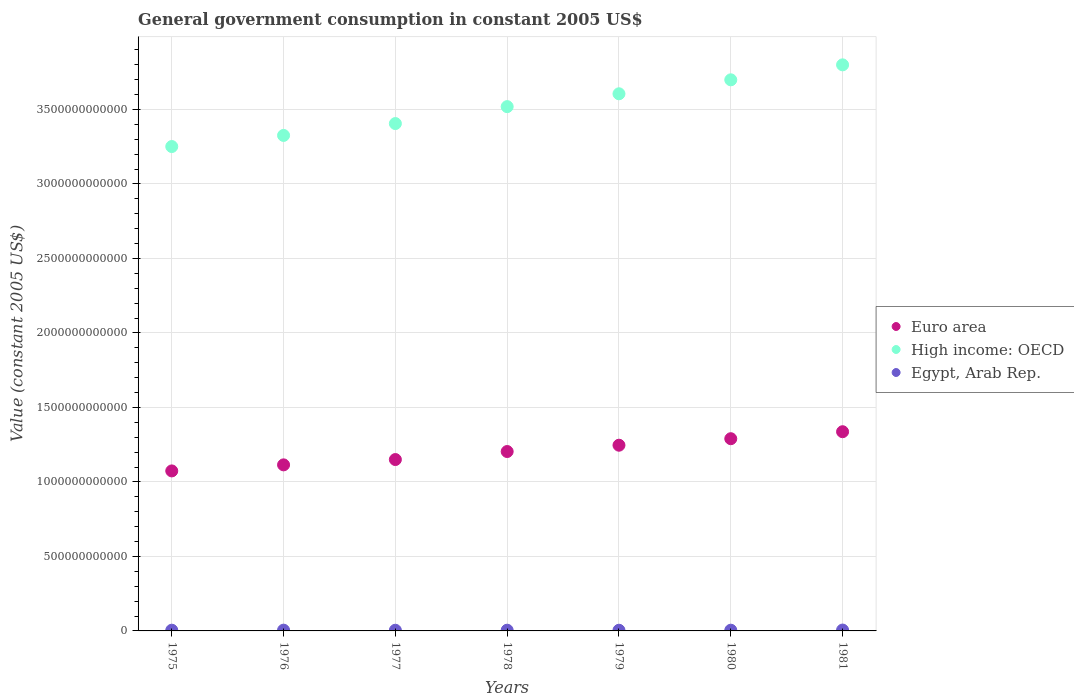How many different coloured dotlines are there?
Offer a very short reply. 3. Is the number of dotlines equal to the number of legend labels?
Provide a short and direct response. Yes. What is the government conusmption in Egypt, Arab Rep. in 1975?
Provide a short and direct response. 4.83e+09. Across all years, what is the maximum government conusmption in Egypt, Arab Rep.?
Give a very brief answer. 5.85e+09. Across all years, what is the minimum government conusmption in High income: OECD?
Offer a terse response. 3.25e+12. In which year was the government conusmption in Euro area maximum?
Offer a terse response. 1981. In which year was the government conusmption in Egypt, Arab Rep. minimum?
Your answer should be very brief. 1979. What is the total government conusmption in Euro area in the graph?
Offer a terse response. 8.42e+12. What is the difference between the government conusmption in Euro area in 1976 and that in 1979?
Make the answer very short. -1.32e+11. What is the difference between the government conusmption in Egypt, Arab Rep. in 1978 and the government conusmption in Euro area in 1977?
Give a very brief answer. -1.15e+12. What is the average government conusmption in Egypt, Arab Rep. per year?
Offer a terse response. 4.94e+09. In the year 1977, what is the difference between the government conusmption in Euro area and government conusmption in Egypt, Arab Rep.?
Offer a very short reply. 1.15e+12. In how many years, is the government conusmption in Euro area greater than 1100000000000 US$?
Provide a short and direct response. 6. What is the ratio of the government conusmption in High income: OECD in 1979 to that in 1980?
Offer a very short reply. 0.97. Is the government conusmption in Euro area in 1977 less than that in 1978?
Keep it short and to the point. Yes. What is the difference between the highest and the second highest government conusmption in High income: OECD?
Your answer should be very brief. 1.01e+11. What is the difference between the highest and the lowest government conusmption in High income: OECD?
Keep it short and to the point. 5.48e+11. Is the sum of the government conusmption in Euro area in 1978 and 1981 greater than the maximum government conusmption in Egypt, Arab Rep. across all years?
Your response must be concise. Yes. Is it the case that in every year, the sum of the government conusmption in Euro area and government conusmption in Egypt, Arab Rep.  is greater than the government conusmption in High income: OECD?
Keep it short and to the point. No. Does the government conusmption in Egypt, Arab Rep. monotonically increase over the years?
Make the answer very short. No. Is the government conusmption in Euro area strictly greater than the government conusmption in Egypt, Arab Rep. over the years?
Give a very brief answer. Yes. Is the government conusmption in Euro area strictly less than the government conusmption in High income: OECD over the years?
Provide a succinct answer. Yes. How many dotlines are there?
Offer a very short reply. 3. How many years are there in the graph?
Provide a short and direct response. 7. What is the difference between two consecutive major ticks on the Y-axis?
Provide a short and direct response. 5.00e+11. Are the values on the major ticks of Y-axis written in scientific E-notation?
Offer a very short reply. No. Does the graph contain any zero values?
Offer a terse response. No. Does the graph contain grids?
Ensure brevity in your answer.  Yes. Where does the legend appear in the graph?
Offer a very short reply. Center right. How many legend labels are there?
Offer a terse response. 3. How are the legend labels stacked?
Your response must be concise. Vertical. What is the title of the graph?
Your response must be concise. General government consumption in constant 2005 US$. What is the label or title of the Y-axis?
Provide a succinct answer. Value (constant 2005 US$). What is the Value (constant 2005 US$) of Euro area in 1975?
Your response must be concise. 1.07e+12. What is the Value (constant 2005 US$) in High income: OECD in 1975?
Your answer should be compact. 3.25e+12. What is the Value (constant 2005 US$) of Egypt, Arab Rep. in 1975?
Give a very brief answer. 4.83e+09. What is the Value (constant 2005 US$) in Euro area in 1976?
Provide a succinct answer. 1.11e+12. What is the Value (constant 2005 US$) of High income: OECD in 1976?
Keep it short and to the point. 3.33e+12. What is the Value (constant 2005 US$) in Egypt, Arab Rep. in 1976?
Your answer should be compact. 5.14e+09. What is the Value (constant 2005 US$) in Euro area in 1977?
Give a very brief answer. 1.15e+12. What is the Value (constant 2005 US$) in High income: OECD in 1977?
Give a very brief answer. 3.41e+12. What is the Value (constant 2005 US$) of Egypt, Arab Rep. in 1977?
Ensure brevity in your answer.  4.53e+09. What is the Value (constant 2005 US$) of Euro area in 1978?
Provide a short and direct response. 1.20e+12. What is the Value (constant 2005 US$) in High income: OECD in 1978?
Your answer should be compact. 3.52e+12. What is the Value (constant 2005 US$) in Egypt, Arab Rep. in 1978?
Offer a very short reply. 4.90e+09. What is the Value (constant 2005 US$) of Euro area in 1979?
Your answer should be compact. 1.25e+12. What is the Value (constant 2005 US$) of High income: OECD in 1979?
Provide a short and direct response. 3.61e+12. What is the Value (constant 2005 US$) of Egypt, Arab Rep. in 1979?
Give a very brief answer. 4.53e+09. What is the Value (constant 2005 US$) in Euro area in 1980?
Offer a terse response. 1.29e+12. What is the Value (constant 2005 US$) in High income: OECD in 1980?
Your answer should be compact. 3.70e+12. What is the Value (constant 2005 US$) in Egypt, Arab Rep. in 1980?
Your answer should be very brief. 4.83e+09. What is the Value (constant 2005 US$) in Euro area in 1981?
Offer a terse response. 1.34e+12. What is the Value (constant 2005 US$) in High income: OECD in 1981?
Provide a succinct answer. 3.80e+12. What is the Value (constant 2005 US$) of Egypt, Arab Rep. in 1981?
Provide a short and direct response. 5.85e+09. Across all years, what is the maximum Value (constant 2005 US$) of Euro area?
Provide a short and direct response. 1.34e+12. Across all years, what is the maximum Value (constant 2005 US$) in High income: OECD?
Offer a very short reply. 3.80e+12. Across all years, what is the maximum Value (constant 2005 US$) of Egypt, Arab Rep.?
Your answer should be very brief. 5.85e+09. Across all years, what is the minimum Value (constant 2005 US$) of Euro area?
Your response must be concise. 1.07e+12. Across all years, what is the minimum Value (constant 2005 US$) of High income: OECD?
Keep it short and to the point. 3.25e+12. Across all years, what is the minimum Value (constant 2005 US$) of Egypt, Arab Rep.?
Give a very brief answer. 4.53e+09. What is the total Value (constant 2005 US$) in Euro area in the graph?
Provide a short and direct response. 8.42e+12. What is the total Value (constant 2005 US$) in High income: OECD in the graph?
Keep it short and to the point. 2.46e+13. What is the total Value (constant 2005 US$) in Egypt, Arab Rep. in the graph?
Offer a terse response. 3.46e+1. What is the difference between the Value (constant 2005 US$) of Euro area in 1975 and that in 1976?
Offer a terse response. -4.07e+1. What is the difference between the Value (constant 2005 US$) in High income: OECD in 1975 and that in 1976?
Keep it short and to the point. -7.46e+1. What is the difference between the Value (constant 2005 US$) of Egypt, Arab Rep. in 1975 and that in 1976?
Ensure brevity in your answer.  -3.16e+08. What is the difference between the Value (constant 2005 US$) in Euro area in 1975 and that in 1977?
Ensure brevity in your answer.  -7.63e+1. What is the difference between the Value (constant 2005 US$) in High income: OECD in 1975 and that in 1977?
Give a very brief answer. -1.54e+11. What is the difference between the Value (constant 2005 US$) of Egypt, Arab Rep. in 1975 and that in 1977?
Provide a succinct answer. 2.92e+08. What is the difference between the Value (constant 2005 US$) in Euro area in 1975 and that in 1978?
Your response must be concise. -1.30e+11. What is the difference between the Value (constant 2005 US$) in High income: OECD in 1975 and that in 1978?
Keep it short and to the point. -2.68e+11. What is the difference between the Value (constant 2005 US$) in Egypt, Arab Rep. in 1975 and that in 1978?
Provide a succinct answer. -7.05e+07. What is the difference between the Value (constant 2005 US$) in Euro area in 1975 and that in 1979?
Keep it short and to the point. -1.73e+11. What is the difference between the Value (constant 2005 US$) in High income: OECD in 1975 and that in 1979?
Your response must be concise. -3.54e+11. What is the difference between the Value (constant 2005 US$) in Egypt, Arab Rep. in 1975 and that in 1979?
Your answer should be compact. 2.98e+08. What is the difference between the Value (constant 2005 US$) of Euro area in 1975 and that in 1980?
Provide a succinct answer. -2.16e+11. What is the difference between the Value (constant 2005 US$) in High income: OECD in 1975 and that in 1980?
Give a very brief answer. -4.48e+11. What is the difference between the Value (constant 2005 US$) of Egypt, Arab Rep. in 1975 and that in 1980?
Offer a terse response. -2.20e+06. What is the difference between the Value (constant 2005 US$) of Euro area in 1975 and that in 1981?
Provide a succinct answer. -2.63e+11. What is the difference between the Value (constant 2005 US$) in High income: OECD in 1975 and that in 1981?
Offer a very short reply. -5.48e+11. What is the difference between the Value (constant 2005 US$) of Egypt, Arab Rep. in 1975 and that in 1981?
Provide a succinct answer. -1.02e+09. What is the difference between the Value (constant 2005 US$) of Euro area in 1976 and that in 1977?
Provide a succinct answer. -3.57e+1. What is the difference between the Value (constant 2005 US$) of High income: OECD in 1976 and that in 1977?
Your answer should be very brief. -7.96e+1. What is the difference between the Value (constant 2005 US$) of Egypt, Arab Rep. in 1976 and that in 1977?
Provide a short and direct response. 6.08e+08. What is the difference between the Value (constant 2005 US$) in Euro area in 1976 and that in 1978?
Keep it short and to the point. -8.95e+1. What is the difference between the Value (constant 2005 US$) in High income: OECD in 1976 and that in 1978?
Ensure brevity in your answer.  -1.93e+11. What is the difference between the Value (constant 2005 US$) in Egypt, Arab Rep. in 1976 and that in 1978?
Your response must be concise. 2.46e+08. What is the difference between the Value (constant 2005 US$) in Euro area in 1976 and that in 1979?
Keep it short and to the point. -1.32e+11. What is the difference between the Value (constant 2005 US$) of High income: OECD in 1976 and that in 1979?
Give a very brief answer. -2.79e+11. What is the difference between the Value (constant 2005 US$) of Egypt, Arab Rep. in 1976 and that in 1979?
Make the answer very short. 6.15e+08. What is the difference between the Value (constant 2005 US$) in Euro area in 1976 and that in 1980?
Make the answer very short. -1.76e+11. What is the difference between the Value (constant 2005 US$) in High income: OECD in 1976 and that in 1980?
Ensure brevity in your answer.  -3.73e+11. What is the difference between the Value (constant 2005 US$) of Egypt, Arab Rep. in 1976 and that in 1980?
Your response must be concise. 3.14e+08. What is the difference between the Value (constant 2005 US$) of Euro area in 1976 and that in 1981?
Give a very brief answer. -2.22e+11. What is the difference between the Value (constant 2005 US$) of High income: OECD in 1976 and that in 1981?
Your answer should be compact. -4.74e+11. What is the difference between the Value (constant 2005 US$) in Egypt, Arab Rep. in 1976 and that in 1981?
Your response must be concise. -7.06e+08. What is the difference between the Value (constant 2005 US$) of Euro area in 1977 and that in 1978?
Keep it short and to the point. -5.39e+1. What is the difference between the Value (constant 2005 US$) in High income: OECD in 1977 and that in 1978?
Provide a short and direct response. -1.14e+11. What is the difference between the Value (constant 2005 US$) of Egypt, Arab Rep. in 1977 and that in 1978?
Your answer should be very brief. -3.62e+08. What is the difference between the Value (constant 2005 US$) of Euro area in 1977 and that in 1979?
Provide a short and direct response. -9.62e+1. What is the difference between the Value (constant 2005 US$) of High income: OECD in 1977 and that in 1979?
Your answer should be compact. -2.00e+11. What is the difference between the Value (constant 2005 US$) in Egypt, Arab Rep. in 1977 and that in 1979?
Your answer should be compact. 6.61e+06. What is the difference between the Value (constant 2005 US$) in Euro area in 1977 and that in 1980?
Keep it short and to the point. -1.40e+11. What is the difference between the Value (constant 2005 US$) of High income: OECD in 1977 and that in 1980?
Make the answer very short. -2.94e+11. What is the difference between the Value (constant 2005 US$) of Egypt, Arab Rep. in 1977 and that in 1980?
Your answer should be compact. -2.94e+08. What is the difference between the Value (constant 2005 US$) in Euro area in 1977 and that in 1981?
Your answer should be compact. -1.87e+11. What is the difference between the Value (constant 2005 US$) in High income: OECD in 1977 and that in 1981?
Offer a terse response. -3.94e+11. What is the difference between the Value (constant 2005 US$) of Egypt, Arab Rep. in 1977 and that in 1981?
Your response must be concise. -1.31e+09. What is the difference between the Value (constant 2005 US$) in Euro area in 1978 and that in 1979?
Give a very brief answer. -4.24e+1. What is the difference between the Value (constant 2005 US$) of High income: OECD in 1978 and that in 1979?
Offer a terse response. -8.62e+1. What is the difference between the Value (constant 2005 US$) of Egypt, Arab Rep. in 1978 and that in 1979?
Offer a very short reply. 3.69e+08. What is the difference between the Value (constant 2005 US$) in Euro area in 1978 and that in 1980?
Provide a short and direct response. -8.60e+1. What is the difference between the Value (constant 2005 US$) in High income: OECD in 1978 and that in 1980?
Make the answer very short. -1.80e+11. What is the difference between the Value (constant 2005 US$) in Egypt, Arab Rep. in 1978 and that in 1980?
Your response must be concise. 6.83e+07. What is the difference between the Value (constant 2005 US$) in Euro area in 1978 and that in 1981?
Offer a very short reply. -1.33e+11. What is the difference between the Value (constant 2005 US$) in High income: OECD in 1978 and that in 1981?
Provide a short and direct response. -2.80e+11. What is the difference between the Value (constant 2005 US$) in Egypt, Arab Rep. in 1978 and that in 1981?
Your answer should be compact. -9.52e+08. What is the difference between the Value (constant 2005 US$) of Euro area in 1979 and that in 1980?
Make the answer very short. -4.37e+1. What is the difference between the Value (constant 2005 US$) in High income: OECD in 1979 and that in 1980?
Keep it short and to the point. -9.37e+1. What is the difference between the Value (constant 2005 US$) in Egypt, Arab Rep. in 1979 and that in 1980?
Your answer should be compact. -3.01e+08. What is the difference between the Value (constant 2005 US$) in Euro area in 1979 and that in 1981?
Your answer should be very brief. -9.06e+1. What is the difference between the Value (constant 2005 US$) of High income: OECD in 1979 and that in 1981?
Your response must be concise. -1.94e+11. What is the difference between the Value (constant 2005 US$) in Egypt, Arab Rep. in 1979 and that in 1981?
Ensure brevity in your answer.  -1.32e+09. What is the difference between the Value (constant 2005 US$) in Euro area in 1980 and that in 1981?
Keep it short and to the point. -4.69e+1. What is the difference between the Value (constant 2005 US$) of High income: OECD in 1980 and that in 1981?
Give a very brief answer. -1.01e+11. What is the difference between the Value (constant 2005 US$) in Egypt, Arab Rep. in 1980 and that in 1981?
Offer a very short reply. -1.02e+09. What is the difference between the Value (constant 2005 US$) in Euro area in 1975 and the Value (constant 2005 US$) in High income: OECD in 1976?
Your answer should be compact. -2.25e+12. What is the difference between the Value (constant 2005 US$) of Euro area in 1975 and the Value (constant 2005 US$) of Egypt, Arab Rep. in 1976?
Provide a short and direct response. 1.07e+12. What is the difference between the Value (constant 2005 US$) in High income: OECD in 1975 and the Value (constant 2005 US$) in Egypt, Arab Rep. in 1976?
Your answer should be compact. 3.25e+12. What is the difference between the Value (constant 2005 US$) of Euro area in 1975 and the Value (constant 2005 US$) of High income: OECD in 1977?
Your response must be concise. -2.33e+12. What is the difference between the Value (constant 2005 US$) of Euro area in 1975 and the Value (constant 2005 US$) of Egypt, Arab Rep. in 1977?
Your answer should be very brief. 1.07e+12. What is the difference between the Value (constant 2005 US$) in High income: OECD in 1975 and the Value (constant 2005 US$) in Egypt, Arab Rep. in 1977?
Ensure brevity in your answer.  3.25e+12. What is the difference between the Value (constant 2005 US$) in Euro area in 1975 and the Value (constant 2005 US$) in High income: OECD in 1978?
Provide a short and direct response. -2.44e+12. What is the difference between the Value (constant 2005 US$) in Euro area in 1975 and the Value (constant 2005 US$) in Egypt, Arab Rep. in 1978?
Keep it short and to the point. 1.07e+12. What is the difference between the Value (constant 2005 US$) of High income: OECD in 1975 and the Value (constant 2005 US$) of Egypt, Arab Rep. in 1978?
Give a very brief answer. 3.25e+12. What is the difference between the Value (constant 2005 US$) in Euro area in 1975 and the Value (constant 2005 US$) in High income: OECD in 1979?
Offer a very short reply. -2.53e+12. What is the difference between the Value (constant 2005 US$) of Euro area in 1975 and the Value (constant 2005 US$) of Egypt, Arab Rep. in 1979?
Keep it short and to the point. 1.07e+12. What is the difference between the Value (constant 2005 US$) of High income: OECD in 1975 and the Value (constant 2005 US$) of Egypt, Arab Rep. in 1979?
Offer a very short reply. 3.25e+12. What is the difference between the Value (constant 2005 US$) in Euro area in 1975 and the Value (constant 2005 US$) in High income: OECD in 1980?
Make the answer very short. -2.62e+12. What is the difference between the Value (constant 2005 US$) of Euro area in 1975 and the Value (constant 2005 US$) of Egypt, Arab Rep. in 1980?
Ensure brevity in your answer.  1.07e+12. What is the difference between the Value (constant 2005 US$) in High income: OECD in 1975 and the Value (constant 2005 US$) in Egypt, Arab Rep. in 1980?
Give a very brief answer. 3.25e+12. What is the difference between the Value (constant 2005 US$) in Euro area in 1975 and the Value (constant 2005 US$) in High income: OECD in 1981?
Offer a very short reply. -2.73e+12. What is the difference between the Value (constant 2005 US$) in Euro area in 1975 and the Value (constant 2005 US$) in Egypt, Arab Rep. in 1981?
Your answer should be compact. 1.07e+12. What is the difference between the Value (constant 2005 US$) in High income: OECD in 1975 and the Value (constant 2005 US$) in Egypt, Arab Rep. in 1981?
Ensure brevity in your answer.  3.25e+12. What is the difference between the Value (constant 2005 US$) of Euro area in 1976 and the Value (constant 2005 US$) of High income: OECD in 1977?
Ensure brevity in your answer.  -2.29e+12. What is the difference between the Value (constant 2005 US$) in Euro area in 1976 and the Value (constant 2005 US$) in Egypt, Arab Rep. in 1977?
Provide a short and direct response. 1.11e+12. What is the difference between the Value (constant 2005 US$) of High income: OECD in 1976 and the Value (constant 2005 US$) of Egypt, Arab Rep. in 1977?
Your response must be concise. 3.32e+12. What is the difference between the Value (constant 2005 US$) of Euro area in 1976 and the Value (constant 2005 US$) of High income: OECD in 1978?
Offer a very short reply. -2.40e+12. What is the difference between the Value (constant 2005 US$) of Euro area in 1976 and the Value (constant 2005 US$) of Egypt, Arab Rep. in 1978?
Keep it short and to the point. 1.11e+12. What is the difference between the Value (constant 2005 US$) of High income: OECD in 1976 and the Value (constant 2005 US$) of Egypt, Arab Rep. in 1978?
Provide a short and direct response. 3.32e+12. What is the difference between the Value (constant 2005 US$) in Euro area in 1976 and the Value (constant 2005 US$) in High income: OECD in 1979?
Your response must be concise. -2.49e+12. What is the difference between the Value (constant 2005 US$) in Euro area in 1976 and the Value (constant 2005 US$) in Egypt, Arab Rep. in 1979?
Offer a terse response. 1.11e+12. What is the difference between the Value (constant 2005 US$) in High income: OECD in 1976 and the Value (constant 2005 US$) in Egypt, Arab Rep. in 1979?
Ensure brevity in your answer.  3.32e+12. What is the difference between the Value (constant 2005 US$) of Euro area in 1976 and the Value (constant 2005 US$) of High income: OECD in 1980?
Provide a short and direct response. -2.58e+12. What is the difference between the Value (constant 2005 US$) of Euro area in 1976 and the Value (constant 2005 US$) of Egypt, Arab Rep. in 1980?
Ensure brevity in your answer.  1.11e+12. What is the difference between the Value (constant 2005 US$) in High income: OECD in 1976 and the Value (constant 2005 US$) in Egypt, Arab Rep. in 1980?
Your answer should be compact. 3.32e+12. What is the difference between the Value (constant 2005 US$) of Euro area in 1976 and the Value (constant 2005 US$) of High income: OECD in 1981?
Make the answer very short. -2.68e+12. What is the difference between the Value (constant 2005 US$) of Euro area in 1976 and the Value (constant 2005 US$) of Egypt, Arab Rep. in 1981?
Provide a succinct answer. 1.11e+12. What is the difference between the Value (constant 2005 US$) in High income: OECD in 1976 and the Value (constant 2005 US$) in Egypt, Arab Rep. in 1981?
Give a very brief answer. 3.32e+12. What is the difference between the Value (constant 2005 US$) in Euro area in 1977 and the Value (constant 2005 US$) in High income: OECD in 1978?
Provide a succinct answer. -2.37e+12. What is the difference between the Value (constant 2005 US$) in Euro area in 1977 and the Value (constant 2005 US$) in Egypt, Arab Rep. in 1978?
Keep it short and to the point. 1.15e+12. What is the difference between the Value (constant 2005 US$) in High income: OECD in 1977 and the Value (constant 2005 US$) in Egypt, Arab Rep. in 1978?
Ensure brevity in your answer.  3.40e+12. What is the difference between the Value (constant 2005 US$) in Euro area in 1977 and the Value (constant 2005 US$) in High income: OECD in 1979?
Your answer should be compact. -2.45e+12. What is the difference between the Value (constant 2005 US$) in Euro area in 1977 and the Value (constant 2005 US$) in Egypt, Arab Rep. in 1979?
Make the answer very short. 1.15e+12. What is the difference between the Value (constant 2005 US$) in High income: OECD in 1977 and the Value (constant 2005 US$) in Egypt, Arab Rep. in 1979?
Ensure brevity in your answer.  3.40e+12. What is the difference between the Value (constant 2005 US$) of Euro area in 1977 and the Value (constant 2005 US$) of High income: OECD in 1980?
Make the answer very short. -2.55e+12. What is the difference between the Value (constant 2005 US$) in Euro area in 1977 and the Value (constant 2005 US$) in Egypt, Arab Rep. in 1980?
Give a very brief answer. 1.15e+12. What is the difference between the Value (constant 2005 US$) of High income: OECD in 1977 and the Value (constant 2005 US$) of Egypt, Arab Rep. in 1980?
Give a very brief answer. 3.40e+12. What is the difference between the Value (constant 2005 US$) of Euro area in 1977 and the Value (constant 2005 US$) of High income: OECD in 1981?
Offer a very short reply. -2.65e+12. What is the difference between the Value (constant 2005 US$) of Euro area in 1977 and the Value (constant 2005 US$) of Egypt, Arab Rep. in 1981?
Provide a succinct answer. 1.14e+12. What is the difference between the Value (constant 2005 US$) of High income: OECD in 1977 and the Value (constant 2005 US$) of Egypt, Arab Rep. in 1981?
Give a very brief answer. 3.40e+12. What is the difference between the Value (constant 2005 US$) in Euro area in 1978 and the Value (constant 2005 US$) in High income: OECD in 1979?
Your answer should be very brief. -2.40e+12. What is the difference between the Value (constant 2005 US$) in Euro area in 1978 and the Value (constant 2005 US$) in Egypt, Arab Rep. in 1979?
Your answer should be compact. 1.20e+12. What is the difference between the Value (constant 2005 US$) of High income: OECD in 1978 and the Value (constant 2005 US$) of Egypt, Arab Rep. in 1979?
Make the answer very short. 3.51e+12. What is the difference between the Value (constant 2005 US$) of Euro area in 1978 and the Value (constant 2005 US$) of High income: OECD in 1980?
Offer a terse response. -2.49e+12. What is the difference between the Value (constant 2005 US$) of Euro area in 1978 and the Value (constant 2005 US$) of Egypt, Arab Rep. in 1980?
Your answer should be compact. 1.20e+12. What is the difference between the Value (constant 2005 US$) in High income: OECD in 1978 and the Value (constant 2005 US$) in Egypt, Arab Rep. in 1980?
Make the answer very short. 3.51e+12. What is the difference between the Value (constant 2005 US$) in Euro area in 1978 and the Value (constant 2005 US$) in High income: OECD in 1981?
Your answer should be compact. -2.60e+12. What is the difference between the Value (constant 2005 US$) of Euro area in 1978 and the Value (constant 2005 US$) of Egypt, Arab Rep. in 1981?
Provide a succinct answer. 1.20e+12. What is the difference between the Value (constant 2005 US$) in High income: OECD in 1978 and the Value (constant 2005 US$) in Egypt, Arab Rep. in 1981?
Keep it short and to the point. 3.51e+12. What is the difference between the Value (constant 2005 US$) in Euro area in 1979 and the Value (constant 2005 US$) in High income: OECD in 1980?
Make the answer very short. -2.45e+12. What is the difference between the Value (constant 2005 US$) in Euro area in 1979 and the Value (constant 2005 US$) in Egypt, Arab Rep. in 1980?
Offer a terse response. 1.24e+12. What is the difference between the Value (constant 2005 US$) in High income: OECD in 1979 and the Value (constant 2005 US$) in Egypt, Arab Rep. in 1980?
Make the answer very short. 3.60e+12. What is the difference between the Value (constant 2005 US$) of Euro area in 1979 and the Value (constant 2005 US$) of High income: OECD in 1981?
Offer a terse response. -2.55e+12. What is the difference between the Value (constant 2005 US$) in Euro area in 1979 and the Value (constant 2005 US$) in Egypt, Arab Rep. in 1981?
Offer a terse response. 1.24e+12. What is the difference between the Value (constant 2005 US$) in High income: OECD in 1979 and the Value (constant 2005 US$) in Egypt, Arab Rep. in 1981?
Your answer should be very brief. 3.60e+12. What is the difference between the Value (constant 2005 US$) of Euro area in 1980 and the Value (constant 2005 US$) of High income: OECD in 1981?
Ensure brevity in your answer.  -2.51e+12. What is the difference between the Value (constant 2005 US$) in Euro area in 1980 and the Value (constant 2005 US$) in Egypt, Arab Rep. in 1981?
Provide a succinct answer. 1.28e+12. What is the difference between the Value (constant 2005 US$) in High income: OECD in 1980 and the Value (constant 2005 US$) in Egypt, Arab Rep. in 1981?
Provide a short and direct response. 3.69e+12. What is the average Value (constant 2005 US$) in Euro area per year?
Keep it short and to the point. 1.20e+12. What is the average Value (constant 2005 US$) in High income: OECD per year?
Your response must be concise. 3.51e+12. What is the average Value (constant 2005 US$) of Egypt, Arab Rep. per year?
Provide a short and direct response. 4.94e+09. In the year 1975, what is the difference between the Value (constant 2005 US$) of Euro area and Value (constant 2005 US$) of High income: OECD?
Your answer should be compact. -2.18e+12. In the year 1975, what is the difference between the Value (constant 2005 US$) in Euro area and Value (constant 2005 US$) in Egypt, Arab Rep.?
Offer a terse response. 1.07e+12. In the year 1975, what is the difference between the Value (constant 2005 US$) of High income: OECD and Value (constant 2005 US$) of Egypt, Arab Rep.?
Make the answer very short. 3.25e+12. In the year 1976, what is the difference between the Value (constant 2005 US$) in Euro area and Value (constant 2005 US$) in High income: OECD?
Offer a very short reply. -2.21e+12. In the year 1976, what is the difference between the Value (constant 2005 US$) of Euro area and Value (constant 2005 US$) of Egypt, Arab Rep.?
Provide a succinct answer. 1.11e+12. In the year 1976, what is the difference between the Value (constant 2005 US$) in High income: OECD and Value (constant 2005 US$) in Egypt, Arab Rep.?
Offer a very short reply. 3.32e+12. In the year 1977, what is the difference between the Value (constant 2005 US$) of Euro area and Value (constant 2005 US$) of High income: OECD?
Make the answer very short. -2.25e+12. In the year 1977, what is the difference between the Value (constant 2005 US$) in Euro area and Value (constant 2005 US$) in Egypt, Arab Rep.?
Ensure brevity in your answer.  1.15e+12. In the year 1977, what is the difference between the Value (constant 2005 US$) in High income: OECD and Value (constant 2005 US$) in Egypt, Arab Rep.?
Offer a terse response. 3.40e+12. In the year 1978, what is the difference between the Value (constant 2005 US$) of Euro area and Value (constant 2005 US$) of High income: OECD?
Provide a succinct answer. -2.31e+12. In the year 1978, what is the difference between the Value (constant 2005 US$) in Euro area and Value (constant 2005 US$) in Egypt, Arab Rep.?
Give a very brief answer. 1.20e+12. In the year 1978, what is the difference between the Value (constant 2005 US$) in High income: OECD and Value (constant 2005 US$) in Egypt, Arab Rep.?
Ensure brevity in your answer.  3.51e+12. In the year 1979, what is the difference between the Value (constant 2005 US$) of Euro area and Value (constant 2005 US$) of High income: OECD?
Ensure brevity in your answer.  -2.36e+12. In the year 1979, what is the difference between the Value (constant 2005 US$) of Euro area and Value (constant 2005 US$) of Egypt, Arab Rep.?
Keep it short and to the point. 1.24e+12. In the year 1979, what is the difference between the Value (constant 2005 US$) in High income: OECD and Value (constant 2005 US$) in Egypt, Arab Rep.?
Offer a terse response. 3.60e+12. In the year 1980, what is the difference between the Value (constant 2005 US$) in Euro area and Value (constant 2005 US$) in High income: OECD?
Give a very brief answer. -2.41e+12. In the year 1980, what is the difference between the Value (constant 2005 US$) in Euro area and Value (constant 2005 US$) in Egypt, Arab Rep.?
Your response must be concise. 1.29e+12. In the year 1980, what is the difference between the Value (constant 2005 US$) in High income: OECD and Value (constant 2005 US$) in Egypt, Arab Rep.?
Keep it short and to the point. 3.69e+12. In the year 1981, what is the difference between the Value (constant 2005 US$) of Euro area and Value (constant 2005 US$) of High income: OECD?
Your response must be concise. -2.46e+12. In the year 1981, what is the difference between the Value (constant 2005 US$) in Euro area and Value (constant 2005 US$) in Egypt, Arab Rep.?
Make the answer very short. 1.33e+12. In the year 1981, what is the difference between the Value (constant 2005 US$) in High income: OECD and Value (constant 2005 US$) in Egypt, Arab Rep.?
Keep it short and to the point. 3.79e+12. What is the ratio of the Value (constant 2005 US$) of Euro area in 1975 to that in 1976?
Offer a terse response. 0.96. What is the ratio of the Value (constant 2005 US$) in High income: OECD in 1975 to that in 1976?
Ensure brevity in your answer.  0.98. What is the ratio of the Value (constant 2005 US$) of Egypt, Arab Rep. in 1975 to that in 1976?
Your answer should be compact. 0.94. What is the ratio of the Value (constant 2005 US$) of Euro area in 1975 to that in 1977?
Offer a very short reply. 0.93. What is the ratio of the Value (constant 2005 US$) in High income: OECD in 1975 to that in 1977?
Your answer should be very brief. 0.95. What is the ratio of the Value (constant 2005 US$) in Egypt, Arab Rep. in 1975 to that in 1977?
Your answer should be compact. 1.06. What is the ratio of the Value (constant 2005 US$) of Euro area in 1975 to that in 1978?
Your answer should be compact. 0.89. What is the ratio of the Value (constant 2005 US$) of High income: OECD in 1975 to that in 1978?
Your answer should be very brief. 0.92. What is the ratio of the Value (constant 2005 US$) in Egypt, Arab Rep. in 1975 to that in 1978?
Your answer should be very brief. 0.99. What is the ratio of the Value (constant 2005 US$) of Euro area in 1975 to that in 1979?
Provide a short and direct response. 0.86. What is the ratio of the Value (constant 2005 US$) in High income: OECD in 1975 to that in 1979?
Provide a short and direct response. 0.9. What is the ratio of the Value (constant 2005 US$) of Egypt, Arab Rep. in 1975 to that in 1979?
Offer a very short reply. 1.07. What is the ratio of the Value (constant 2005 US$) in Euro area in 1975 to that in 1980?
Provide a succinct answer. 0.83. What is the ratio of the Value (constant 2005 US$) of High income: OECD in 1975 to that in 1980?
Your answer should be very brief. 0.88. What is the ratio of the Value (constant 2005 US$) of Egypt, Arab Rep. in 1975 to that in 1980?
Your answer should be compact. 1. What is the ratio of the Value (constant 2005 US$) in Euro area in 1975 to that in 1981?
Ensure brevity in your answer.  0.8. What is the ratio of the Value (constant 2005 US$) in High income: OECD in 1975 to that in 1981?
Provide a succinct answer. 0.86. What is the ratio of the Value (constant 2005 US$) in Egypt, Arab Rep. in 1975 to that in 1981?
Make the answer very short. 0.83. What is the ratio of the Value (constant 2005 US$) of Euro area in 1976 to that in 1977?
Your answer should be very brief. 0.97. What is the ratio of the Value (constant 2005 US$) of High income: OECD in 1976 to that in 1977?
Offer a very short reply. 0.98. What is the ratio of the Value (constant 2005 US$) of Egypt, Arab Rep. in 1976 to that in 1977?
Provide a short and direct response. 1.13. What is the ratio of the Value (constant 2005 US$) in Euro area in 1976 to that in 1978?
Offer a terse response. 0.93. What is the ratio of the Value (constant 2005 US$) in High income: OECD in 1976 to that in 1978?
Your response must be concise. 0.95. What is the ratio of the Value (constant 2005 US$) in Egypt, Arab Rep. in 1976 to that in 1978?
Your answer should be very brief. 1.05. What is the ratio of the Value (constant 2005 US$) of Euro area in 1976 to that in 1979?
Offer a very short reply. 0.89. What is the ratio of the Value (constant 2005 US$) in High income: OECD in 1976 to that in 1979?
Provide a succinct answer. 0.92. What is the ratio of the Value (constant 2005 US$) of Egypt, Arab Rep. in 1976 to that in 1979?
Give a very brief answer. 1.14. What is the ratio of the Value (constant 2005 US$) in Euro area in 1976 to that in 1980?
Make the answer very short. 0.86. What is the ratio of the Value (constant 2005 US$) of High income: OECD in 1976 to that in 1980?
Give a very brief answer. 0.9. What is the ratio of the Value (constant 2005 US$) in Egypt, Arab Rep. in 1976 to that in 1980?
Give a very brief answer. 1.06. What is the ratio of the Value (constant 2005 US$) of Euro area in 1976 to that in 1981?
Offer a terse response. 0.83. What is the ratio of the Value (constant 2005 US$) in High income: OECD in 1976 to that in 1981?
Offer a terse response. 0.88. What is the ratio of the Value (constant 2005 US$) in Egypt, Arab Rep. in 1976 to that in 1981?
Offer a terse response. 0.88. What is the ratio of the Value (constant 2005 US$) in Euro area in 1977 to that in 1978?
Offer a very short reply. 0.96. What is the ratio of the Value (constant 2005 US$) of Egypt, Arab Rep. in 1977 to that in 1978?
Your answer should be compact. 0.93. What is the ratio of the Value (constant 2005 US$) of Euro area in 1977 to that in 1979?
Provide a short and direct response. 0.92. What is the ratio of the Value (constant 2005 US$) in High income: OECD in 1977 to that in 1979?
Provide a succinct answer. 0.94. What is the ratio of the Value (constant 2005 US$) in Euro area in 1977 to that in 1980?
Your answer should be very brief. 0.89. What is the ratio of the Value (constant 2005 US$) in High income: OECD in 1977 to that in 1980?
Ensure brevity in your answer.  0.92. What is the ratio of the Value (constant 2005 US$) of Egypt, Arab Rep. in 1977 to that in 1980?
Your answer should be very brief. 0.94. What is the ratio of the Value (constant 2005 US$) of Euro area in 1977 to that in 1981?
Provide a succinct answer. 0.86. What is the ratio of the Value (constant 2005 US$) of High income: OECD in 1977 to that in 1981?
Your answer should be compact. 0.9. What is the ratio of the Value (constant 2005 US$) in Egypt, Arab Rep. in 1977 to that in 1981?
Give a very brief answer. 0.78. What is the ratio of the Value (constant 2005 US$) in High income: OECD in 1978 to that in 1979?
Your answer should be very brief. 0.98. What is the ratio of the Value (constant 2005 US$) in Egypt, Arab Rep. in 1978 to that in 1979?
Your answer should be very brief. 1.08. What is the ratio of the Value (constant 2005 US$) of High income: OECD in 1978 to that in 1980?
Offer a very short reply. 0.95. What is the ratio of the Value (constant 2005 US$) of Egypt, Arab Rep. in 1978 to that in 1980?
Offer a very short reply. 1.01. What is the ratio of the Value (constant 2005 US$) in Euro area in 1978 to that in 1981?
Make the answer very short. 0.9. What is the ratio of the Value (constant 2005 US$) in High income: OECD in 1978 to that in 1981?
Provide a succinct answer. 0.93. What is the ratio of the Value (constant 2005 US$) of Egypt, Arab Rep. in 1978 to that in 1981?
Your answer should be very brief. 0.84. What is the ratio of the Value (constant 2005 US$) in Euro area in 1979 to that in 1980?
Your answer should be very brief. 0.97. What is the ratio of the Value (constant 2005 US$) of High income: OECD in 1979 to that in 1980?
Make the answer very short. 0.97. What is the ratio of the Value (constant 2005 US$) in Egypt, Arab Rep. in 1979 to that in 1980?
Your answer should be compact. 0.94. What is the ratio of the Value (constant 2005 US$) in Euro area in 1979 to that in 1981?
Provide a succinct answer. 0.93. What is the ratio of the Value (constant 2005 US$) in High income: OECD in 1979 to that in 1981?
Offer a terse response. 0.95. What is the ratio of the Value (constant 2005 US$) of Egypt, Arab Rep. in 1979 to that in 1981?
Provide a short and direct response. 0.77. What is the ratio of the Value (constant 2005 US$) of Euro area in 1980 to that in 1981?
Provide a short and direct response. 0.96. What is the ratio of the Value (constant 2005 US$) of High income: OECD in 1980 to that in 1981?
Your response must be concise. 0.97. What is the ratio of the Value (constant 2005 US$) in Egypt, Arab Rep. in 1980 to that in 1981?
Your answer should be very brief. 0.83. What is the difference between the highest and the second highest Value (constant 2005 US$) of Euro area?
Make the answer very short. 4.69e+1. What is the difference between the highest and the second highest Value (constant 2005 US$) in High income: OECD?
Offer a very short reply. 1.01e+11. What is the difference between the highest and the second highest Value (constant 2005 US$) of Egypt, Arab Rep.?
Make the answer very short. 7.06e+08. What is the difference between the highest and the lowest Value (constant 2005 US$) of Euro area?
Make the answer very short. 2.63e+11. What is the difference between the highest and the lowest Value (constant 2005 US$) of High income: OECD?
Make the answer very short. 5.48e+11. What is the difference between the highest and the lowest Value (constant 2005 US$) of Egypt, Arab Rep.?
Your answer should be very brief. 1.32e+09. 